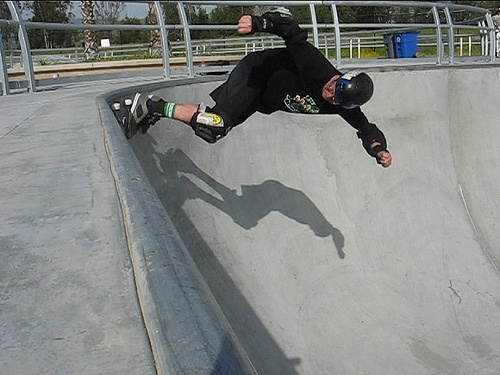Describe the objects in this image and their specific colors. I can see people in black, gray, and darkgray tones and skateboard in black, gray, and purple tones in this image. 